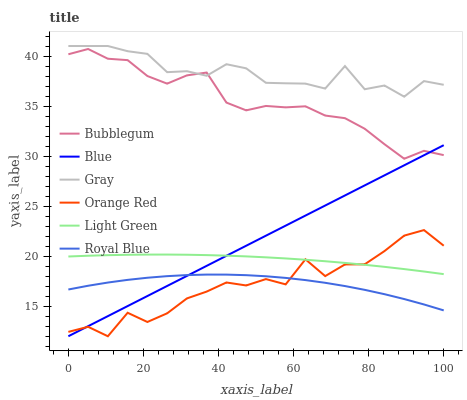Does Bubblegum have the minimum area under the curve?
Answer yes or no. No. Does Bubblegum have the maximum area under the curve?
Answer yes or no. No. Is Gray the smoothest?
Answer yes or no. No. Is Gray the roughest?
Answer yes or no. No. Does Bubblegum have the lowest value?
Answer yes or no. No. Does Bubblegum have the highest value?
Answer yes or no. No. Is Light Green less than Bubblegum?
Answer yes or no. Yes. Is Bubblegum greater than Royal Blue?
Answer yes or no. Yes. Does Light Green intersect Bubblegum?
Answer yes or no. No. 